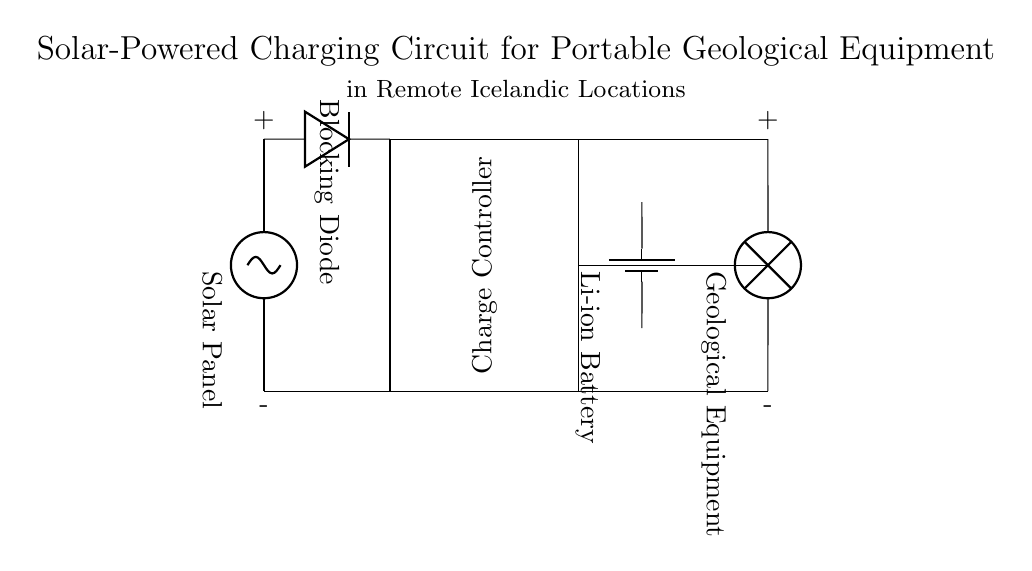What is the main power source in this circuit? The main power source is the solar panel, which is represented at the top left in the diagram. It converts sunlight into electrical energy to charge the battery and power the geological equipment.
Answer: Solar panel What type of battery is used in this circuit? The circuit diagram indicates that a lithium-ion battery is being used, as labeled next to the battery symbol in the diagram. This type of battery is commonly used in portable applications due to its high energy density.
Answer: Li-ion battery Which component prevents current from flowing back to the solar panel? The blocking diode is positioned immediately after the solar panel in the circuit diagram. Its purpose is to allow current to flow only in one direction, preventing any reverse flow that could damage the solar panel.
Answer: Blocking diode How many main components are in the charging circuit? The main components in the circuit are the solar panel, blocking diode, charge controller, lithium-ion battery, and the geological equipment. Counting these visible components gives us a total of five main components.
Answer: Five What is the role of the charge controller in this circuit? The charge controller regulates the voltage and current coming from the solar panel to the battery, ensuring the battery is charged appropriately without overcharging, which can lead to battery damage.
Answer: Regulates charging What does the label 'Geological Equipment' signify in this circuit? The label indicates the load that the circuit is designed to power, specifically equipment used for geological research. It shows where the output energy is utilized in the circuit.
Answer: Load 